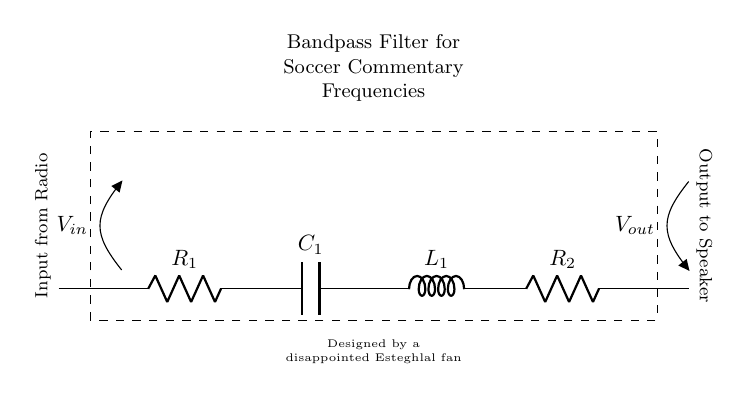What is the type of this filter? This circuit is a bandpass filter, which is indicated in the title of the diagram. A bandpass filter allows a specific range of frequencies to pass through while attenuating frequencies outside that range.
Answer: Bandpass filter What components are used in this circuit? The circuit contains two resistors, one capacitor, and one inductor. These components are labeled in the diagram as R1, R2, C1, and L1.
Answer: Two resistors, one capacitor, one inductor What is the input voltage represented as? The input voltage in the diagram is represented as V in, indicated by the arrow pointing towards the input terminal. This voltage is fed into the circuit from the radio source.
Answer: V in What is the sequence of components from input to output? From the input to the output, the sequence is R1, C1, L1, and R2. This order matters because it affects how the bandpass filter operates.
Answer: R1, C1, L1, R2 Which type of signal connects to this filter? The signal connecting to this filter comes from a radio, as indicated in the label near the input. It suggests that the filter is being used to isolate commentary frequencies typical in soccer broadcasts.
Answer: Radio signal Why is this filter designed specifically for soccer commentary? The label in the diagram states that it is designed to isolate soccer commentary frequencies, suggesting that it is optimized for the frequency range at which such commentary typically occurs. This context implies the filter's purpose.
Answer: To isolate soccer commentary frequencies 